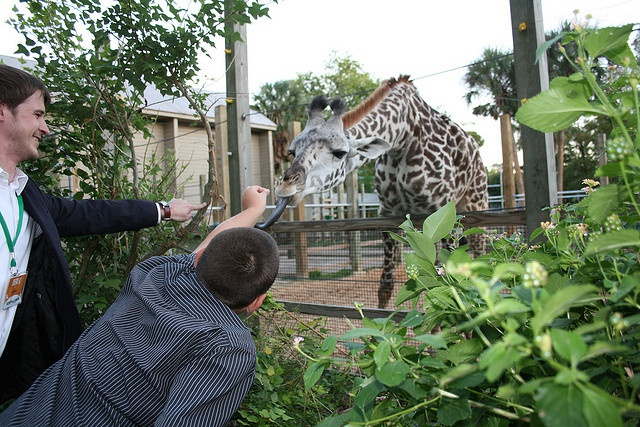Describe the objects in this image and their specific colors. I can see people in white, black, gray, and darkgray tones, giraffe in white, gray, darkgray, black, and lightgray tones, and people in white, black, darkgray, lavender, and gray tones in this image. 